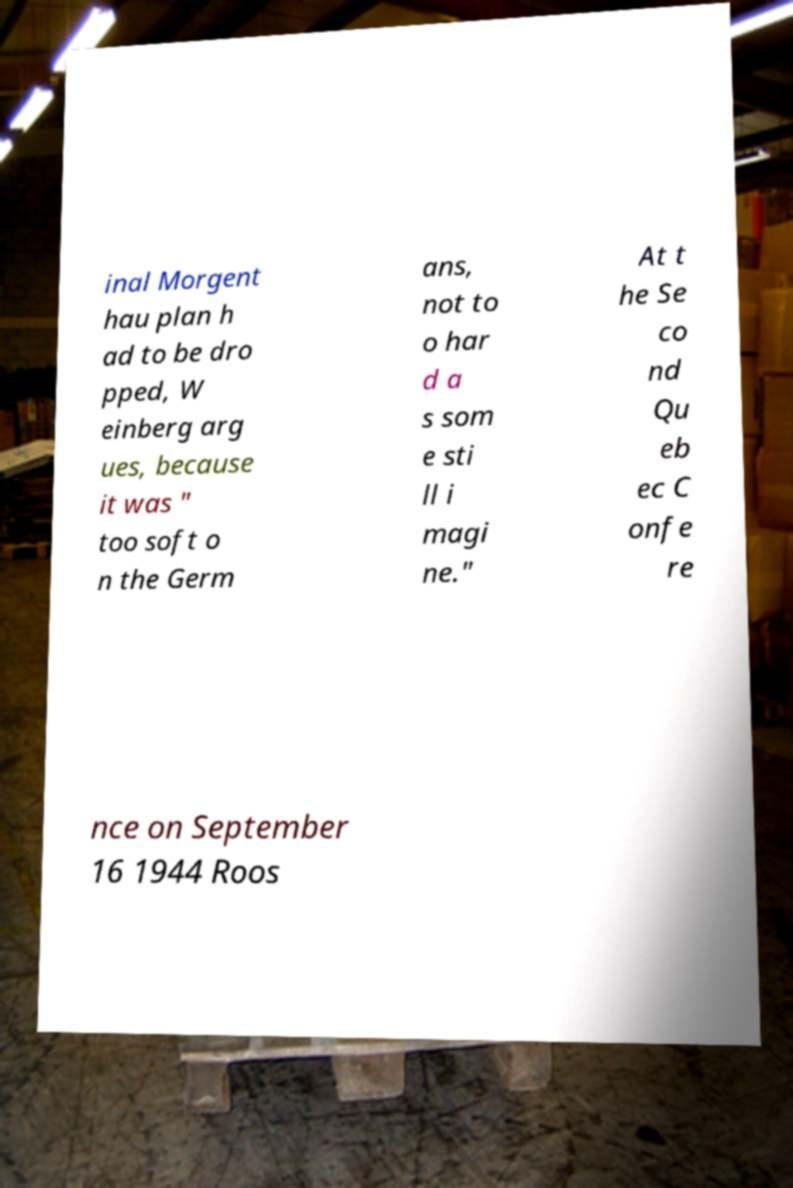Please identify and transcribe the text found in this image. inal Morgent hau plan h ad to be dro pped, W einberg arg ues, because it was " too soft o n the Germ ans, not to o har d a s som e sti ll i magi ne." At t he Se co nd Qu eb ec C onfe re nce on September 16 1944 Roos 